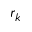Convert formula to latex. <formula><loc_0><loc_0><loc_500><loc_500>r _ { k }</formula> 